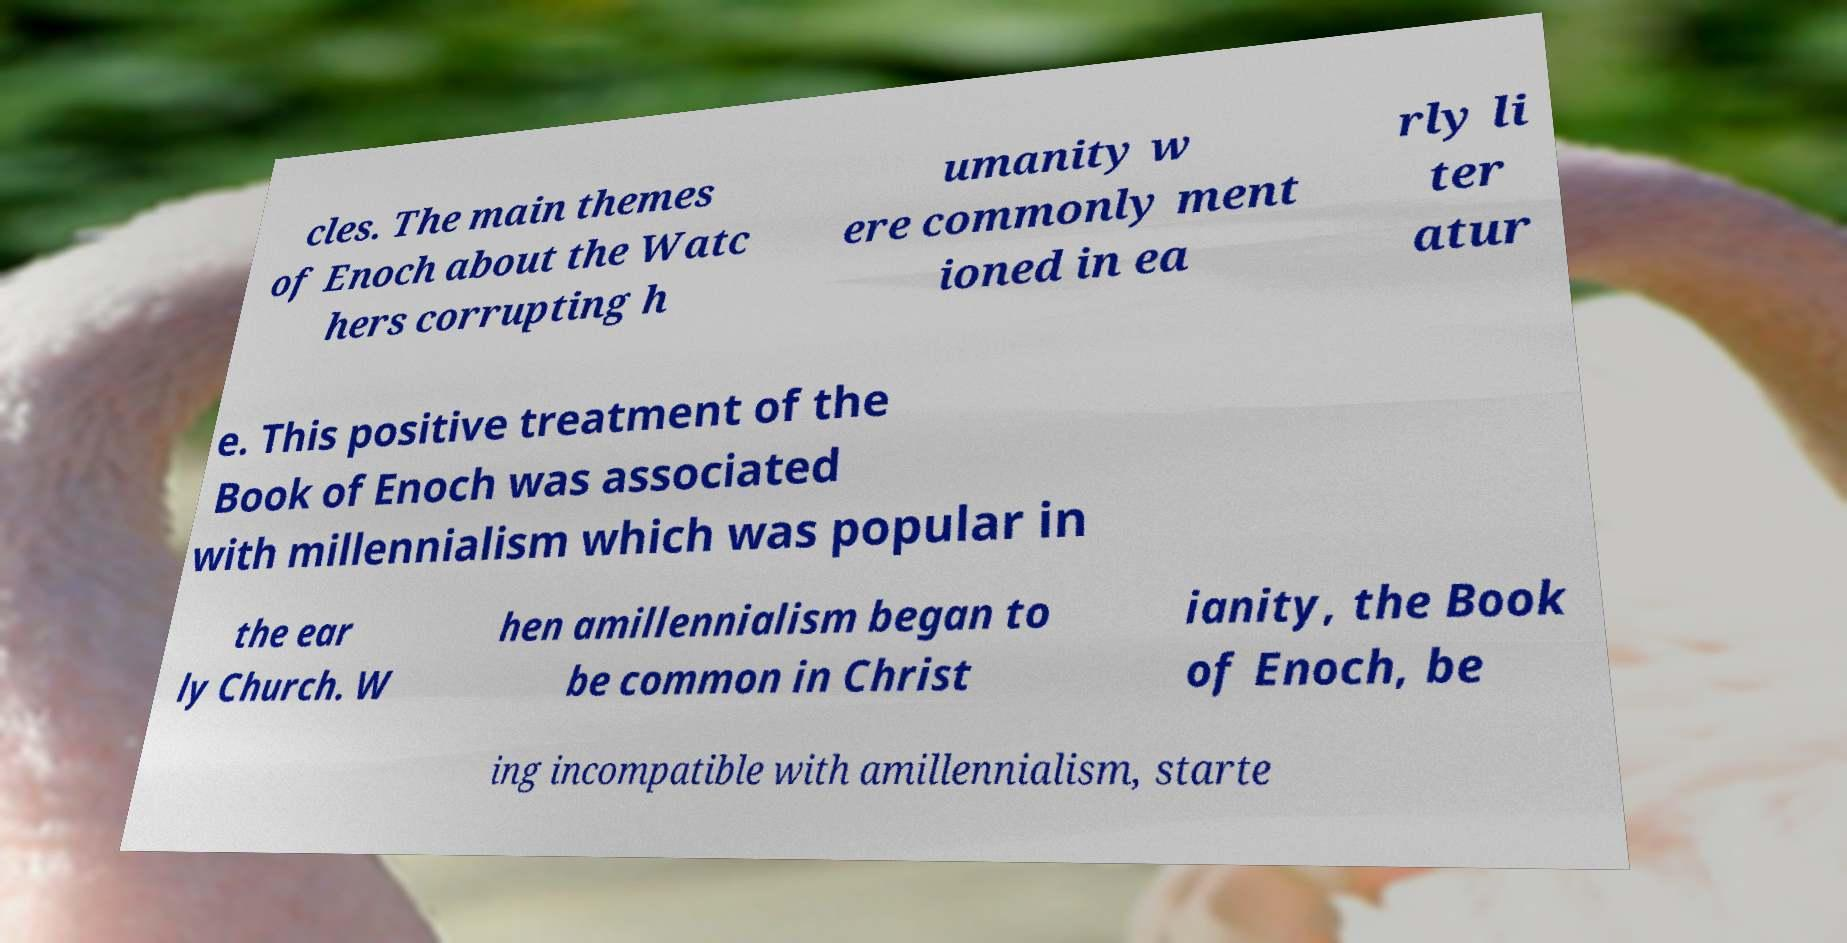What messages or text are displayed in this image? I need them in a readable, typed format. cles. The main themes of Enoch about the Watc hers corrupting h umanity w ere commonly ment ioned in ea rly li ter atur e. This positive treatment of the Book of Enoch was associated with millennialism which was popular in the ear ly Church. W hen amillennialism began to be common in Christ ianity, the Book of Enoch, be ing incompatible with amillennialism, starte 